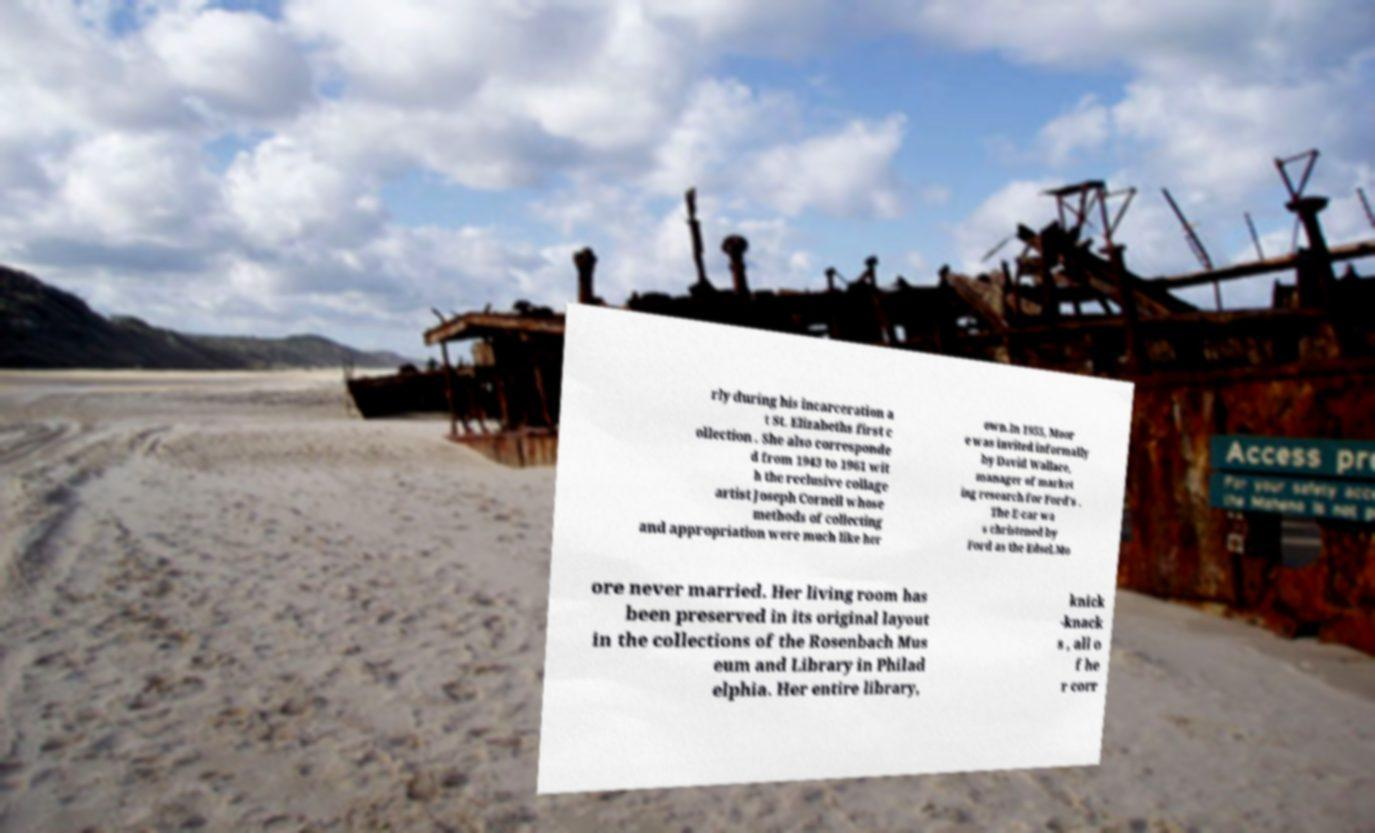What messages or text are displayed in this image? I need them in a readable, typed format. rly during his incarceration a t St. Elizabeths first c ollection . She also corresponde d from 1943 to 1961 wit h the reclusive collage artist Joseph Cornell whose methods of collecting and appropriation were much like her own.In 1955, Moor e was invited informally by David Wallace, manager of market ing research for Ford's . The E-car wa s christened by Ford as the Edsel.Mo ore never married. Her living room has been preserved in its original layout in the collections of the Rosenbach Mus eum and Library in Philad elphia. Her entire library, knick -knack s , all o f he r corr 